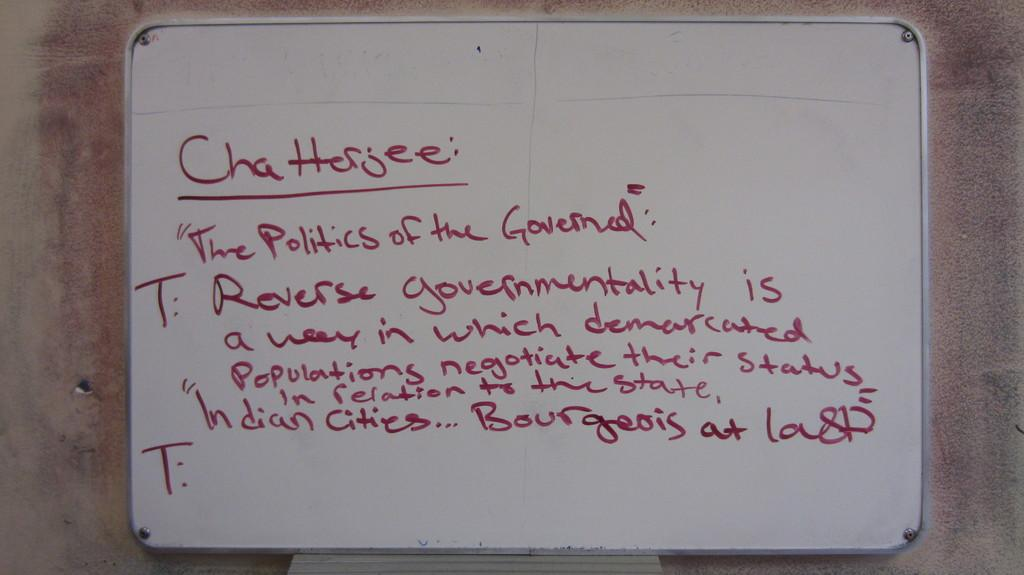<image>
Describe the image concisely. notes on Chatterjee's The polticis of the Governed". 